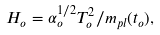Convert formula to latex. <formula><loc_0><loc_0><loc_500><loc_500>H _ { o } = \alpha _ { o } ^ { 1 / 2 } T _ { o } ^ { 2 } / m _ { p l } ( t _ { o } ) ,</formula> 